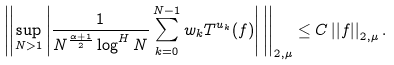<formula> <loc_0><loc_0><loc_500><loc_500>\left | \left | \sup _ { N > 1 } \left | \frac { 1 } { N ^ { \frac { \alpha + 1 } { 2 } } \log ^ { H } N } \sum _ { k = 0 } ^ { N - 1 } w _ { k } T ^ { u _ { k } } ( f ) \right | \, \right | \right | _ { 2 , \mu } \leq C \left | \left | f \right | \right | _ { 2 , \mu } .</formula> 